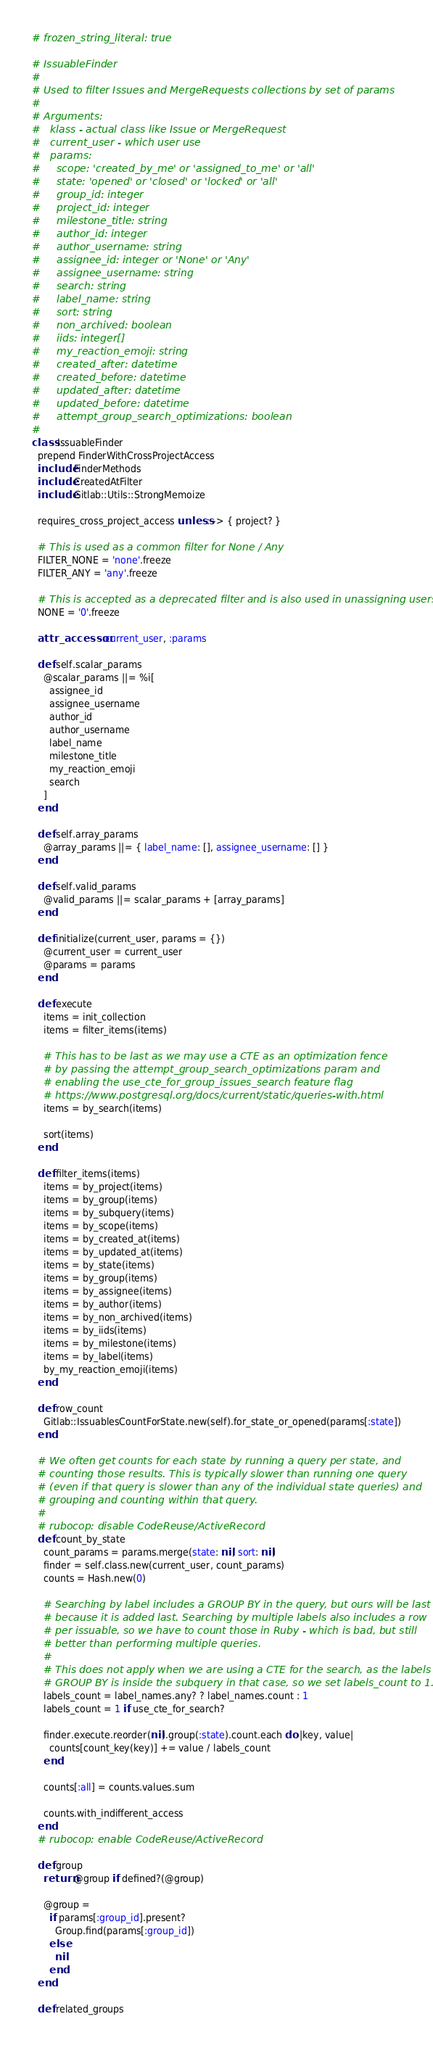Convert code to text. <code><loc_0><loc_0><loc_500><loc_500><_Ruby_># frozen_string_literal: true

# IssuableFinder
#
# Used to filter Issues and MergeRequests collections by set of params
#
# Arguments:
#   klass - actual class like Issue or MergeRequest
#   current_user - which user use
#   params:
#     scope: 'created_by_me' or 'assigned_to_me' or 'all'
#     state: 'opened' or 'closed' or 'locked' or 'all'
#     group_id: integer
#     project_id: integer
#     milestone_title: string
#     author_id: integer
#     author_username: string
#     assignee_id: integer or 'None' or 'Any'
#     assignee_username: string
#     search: string
#     label_name: string
#     sort: string
#     non_archived: boolean
#     iids: integer[]
#     my_reaction_emoji: string
#     created_after: datetime
#     created_before: datetime
#     updated_after: datetime
#     updated_before: datetime
#     attempt_group_search_optimizations: boolean
#
class IssuableFinder
  prepend FinderWithCrossProjectAccess
  include FinderMethods
  include CreatedAtFilter
  include Gitlab::Utils::StrongMemoize

  requires_cross_project_access unless: -> { project? }

  # This is used as a common filter for None / Any
  FILTER_NONE = 'none'.freeze
  FILTER_ANY = 'any'.freeze

  # This is accepted as a deprecated filter and is also used in unassigning users
  NONE = '0'.freeze

  attr_accessor :current_user, :params

  def self.scalar_params
    @scalar_params ||= %i[
      assignee_id
      assignee_username
      author_id
      author_username
      label_name
      milestone_title
      my_reaction_emoji
      search
    ]
  end

  def self.array_params
    @array_params ||= { label_name: [], assignee_username: [] }
  end

  def self.valid_params
    @valid_params ||= scalar_params + [array_params]
  end

  def initialize(current_user, params = {})
    @current_user = current_user
    @params = params
  end

  def execute
    items = init_collection
    items = filter_items(items)

    # This has to be last as we may use a CTE as an optimization fence
    # by passing the attempt_group_search_optimizations param and
    # enabling the use_cte_for_group_issues_search feature flag
    # https://www.postgresql.org/docs/current/static/queries-with.html
    items = by_search(items)

    sort(items)
  end

  def filter_items(items)
    items = by_project(items)
    items = by_group(items)
    items = by_subquery(items)
    items = by_scope(items)
    items = by_created_at(items)
    items = by_updated_at(items)
    items = by_state(items)
    items = by_group(items)
    items = by_assignee(items)
    items = by_author(items)
    items = by_non_archived(items)
    items = by_iids(items)
    items = by_milestone(items)
    items = by_label(items)
    by_my_reaction_emoji(items)
  end

  def row_count
    Gitlab::IssuablesCountForState.new(self).for_state_or_opened(params[:state])
  end

  # We often get counts for each state by running a query per state, and
  # counting those results. This is typically slower than running one query
  # (even if that query is slower than any of the individual state queries) and
  # grouping and counting within that query.
  #
  # rubocop: disable CodeReuse/ActiveRecord
  def count_by_state
    count_params = params.merge(state: nil, sort: nil)
    finder = self.class.new(current_user, count_params)
    counts = Hash.new(0)

    # Searching by label includes a GROUP BY in the query, but ours will be last
    # because it is added last. Searching by multiple labels also includes a row
    # per issuable, so we have to count those in Ruby - which is bad, but still
    # better than performing multiple queries.
    #
    # This does not apply when we are using a CTE for the search, as the labels
    # GROUP BY is inside the subquery in that case, so we set labels_count to 1.
    labels_count = label_names.any? ? label_names.count : 1
    labels_count = 1 if use_cte_for_search?

    finder.execute.reorder(nil).group(:state).count.each do |key, value|
      counts[count_key(key)] += value / labels_count
    end

    counts[:all] = counts.values.sum

    counts.with_indifferent_access
  end
  # rubocop: enable CodeReuse/ActiveRecord

  def group
    return @group if defined?(@group)

    @group =
      if params[:group_id].present?
        Group.find(params[:group_id])
      else
        nil
      end
  end

  def related_groups</code> 